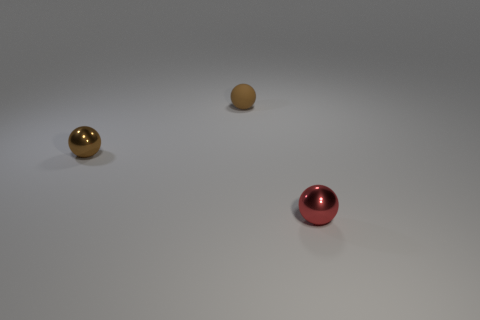Subtract all tiny brown rubber balls. How many balls are left? 2 Subtract all brown blocks. How many brown balls are left? 2 Subtract 1 balls. How many balls are left? 2 Add 2 tiny red spheres. How many objects exist? 5 Add 3 balls. How many balls are left? 6 Add 1 large purple matte objects. How many large purple matte objects exist? 1 Subtract 0 brown blocks. How many objects are left? 3 Subtract all green balls. Subtract all blue cubes. How many balls are left? 3 Subtract all small brown objects. Subtract all red shiny things. How many objects are left? 0 